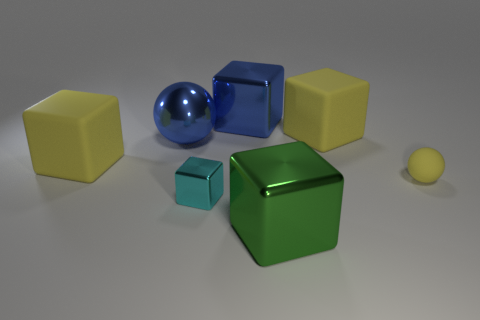Subtract 2 blocks. How many blocks are left? 3 Subtract all blue cubes. How many cubes are left? 4 Subtract all large green cubes. How many cubes are left? 4 Subtract all purple cubes. Subtract all green cylinders. How many cubes are left? 5 Add 1 blue shiny things. How many objects exist? 8 Subtract all cubes. How many objects are left? 2 Subtract 0 gray cubes. How many objects are left? 7 Subtract all big cyan metal cylinders. Subtract all small yellow things. How many objects are left? 6 Add 6 large green metallic things. How many large green metallic things are left? 7 Add 2 cyan shiny objects. How many cyan shiny objects exist? 3 